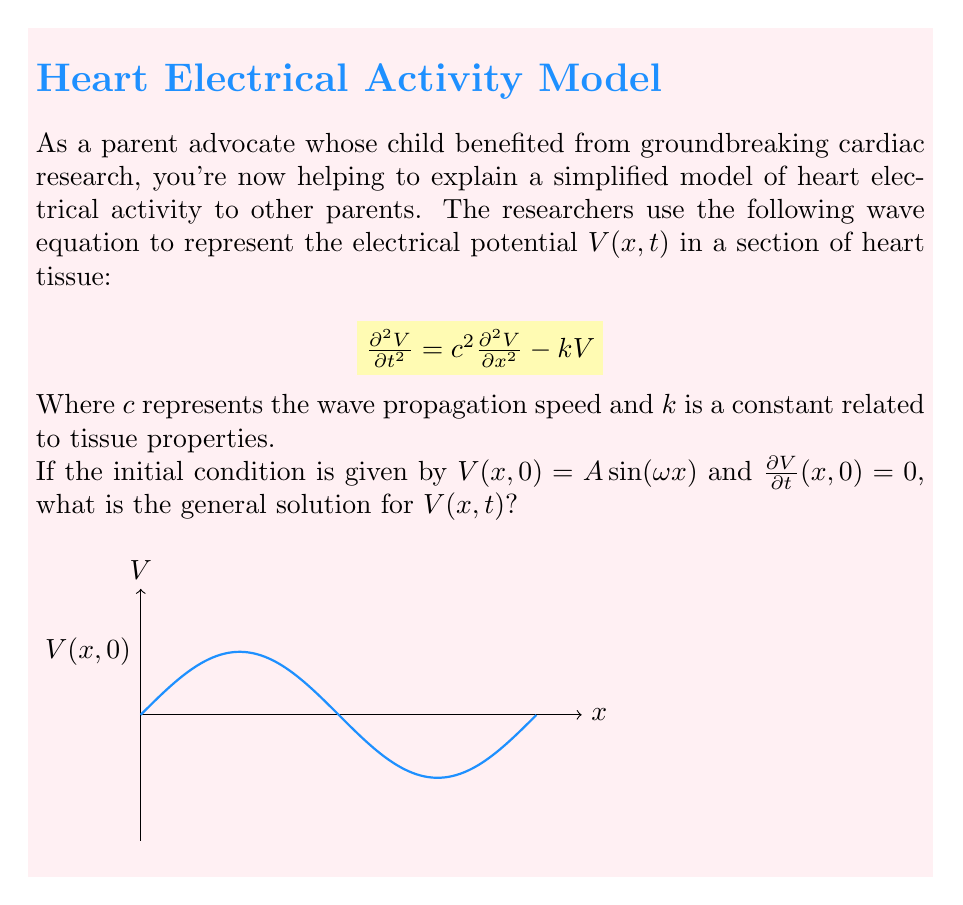Teach me how to tackle this problem. Let's solve this step-by-step:

1) The general solution for this type of wave equation is of the form:
   $$V(x,t) = X(x)T(t)$$

2) Substituting this into the original equation:
   $$X(x)T''(t) = c^2X''(x)T(t) - kX(x)T(t)$$

3) Separating variables:
   $$\frac{T''(t)}{T(t)} = c^2\frac{X''(x)}{X(x)} - k = -\lambda$$
   where $\lambda$ is a separation constant.

4) This gives us two equations:
   $$T''(t) + \lambda T(t) = 0$$
   $$c^2X''(x) + (\lambda - k)X(x) = 0$$

5) The solution for $X(x)$ must satisfy the initial condition $V(x,0) = A \sin(\omega x)$, so:
   $$X(x) = A \sin(\omega x)$$

6) Substituting this into the $X$ equation:
   $$-c^2\omega^2 + (\lambda - k) = 0$$
   $$\lambda = c^2\omega^2 + k$$

7) The $T$ equation becomes:
   $$T''(t) + (c^2\omega^2 + k)T(t) = 0$$

8) The general solution for this is:
   $$T(t) = B \cos(\sqrt{c^2\omega^2 + k}t) + C \sin(\sqrt{c^2\omega^2 + k}t)$$

9) Using the initial condition $\frac{\partial V}{\partial t}(x,0) = 0$, we find that $C = 0$.

10) Therefore, the general solution is:
    $$V(x,t) = A \sin(\omega x) \cos(\sqrt{c^2\omega^2 + k}t)$$
Answer: $V(x,t) = A \sin(\omega x) \cos(\sqrt{c^2\omega^2 + k}t)$ 